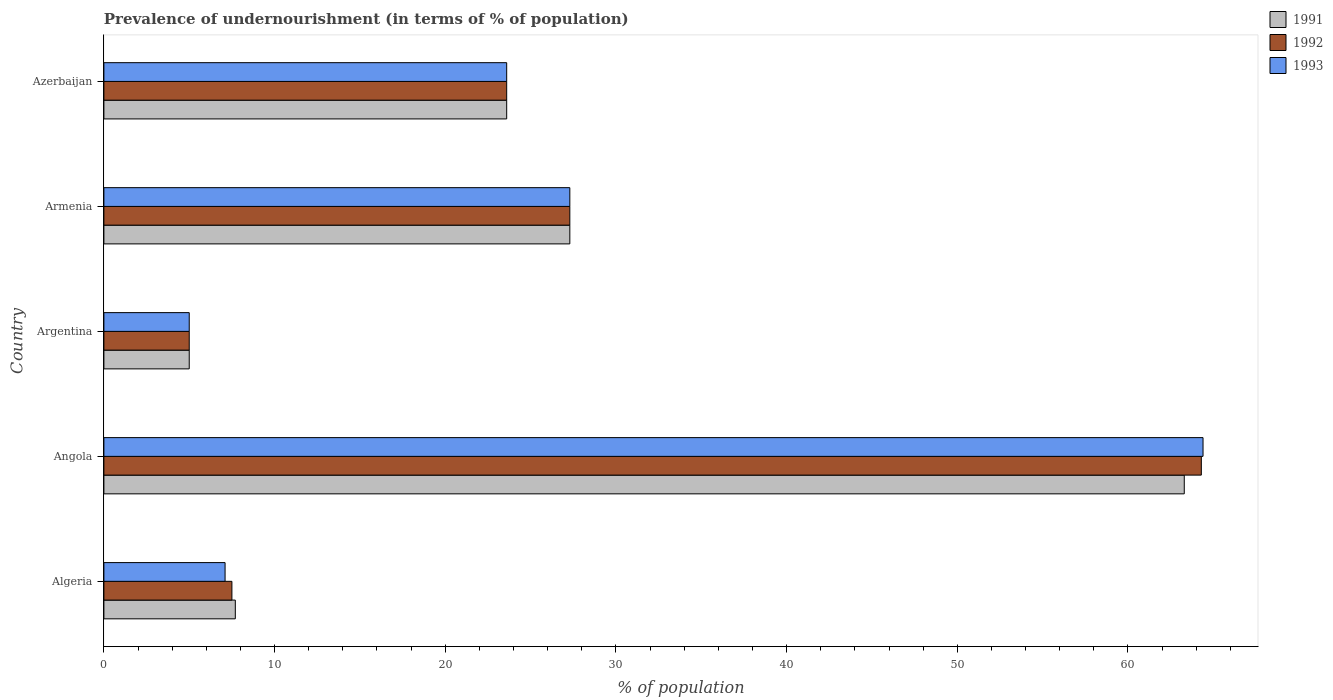What is the label of the 2nd group of bars from the top?
Your answer should be compact. Armenia. What is the percentage of undernourished population in 1991 in Angola?
Make the answer very short. 63.3. Across all countries, what is the maximum percentage of undernourished population in 1992?
Make the answer very short. 64.3. Across all countries, what is the minimum percentage of undernourished population in 1993?
Offer a very short reply. 5. In which country was the percentage of undernourished population in 1991 maximum?
Make the answer very short. Angola. What is the total percentage of undernourished population in 1992 in the graph?
Provide a short and direct response. 127.7. What is the difference between the percentage of undernourished population in 1993 in Algeria and that in Armenia?
Give a very brief answer. -20.2. What is the average percentage of undernourished population in 1992 per country?
Provide a short and direct response. 25.54. What is the difference between the percentage of undernourished population in 1993 and percentage of undernourished population in 1991 in Azerbaijan?
Give a very brief answer. 0. What is the ratio of the percentage of undernourished population in 1991 in Angola to that in Argentina?
Your answer should be very brief. 12.66. Is the percentage of undernourished population in 1993 in Argentina less than that in Azerbaijan?
Keep it short and to the point. Yes. Is the difference between the percentage of undernourished population in 1993 in Armenia and Azerbaijan greater than the difference between the percentage of undernourished population in 1991 in Armenia and Azerbaijan?
Ensure brevity in your answer.  No. What is the difference between the highest and the second highest percentage of undernourished population in 1992?
Make the answer very short. 37. What is the difference between the highest and the lowest percentage of undernourished population in 1991?
Offer a very short reply. 58.3. What does the 3rd bar from the bottom in Angola represents?
Ensure brevity in your answer.  1993. Is it the case that in every country, the sum of the percentage of undernourished population in 1993 and percentage of undernourished population in 1991 is greater than the percentage of undernourished population in 1992?
Provide a short and direct response. Yes. How many bars are there?
Make the answer very short. 15. Are all the bars in the graph horizontal?
Provide a succinct answer. Yes. How many countries are there in the graph?
Your response must be concise. 5. What is the difference between two consecutive major ticks on the X-axis?
Your response must be concise. 10. Where does the legend appear in the graph?
Make the answer very short. Top right. How many legend labels are there?
Make the answer very short. 3. What is the title of the graph?
Provide a succinct answer. Prevalence of undernourishment (in terms of % of population). What is the label or title of the X-axis?
Your response must be concise. % of population. What is the label or title of the Y-axis?
Your response must be concise. Country. What is the % of population of 1992 in Algeria?
Your answer should be very brief. 7.5. What is the % of population of 1991 in Angola?
Offer a very short reply. 63.3. What is the % of population in 1992 in Angola?
Your answer should be compact. 64.3. What is the % of population in 1993 in Angola?
Offer a terse response. 64.4. What is the % of population of 1993 in Argentina?
Your response must be concise. 5. What is the % of population of 1991 in Armenia?
Your answer should be compact. 27.3. What is the % of population of 1992 in Armenia?
Ensure brevity in your answer.  27.3. What is the % of population in 1993 in Armenia?
Provide a succinct answer. 27.3. What is the % of population of 1991 in Azerbaijan?
Provide a succinct answer. 23.6. What is the % of population of 1992 in Azerbaijan?
Keep it short and to the point. 23.6. What is the % of population in 1993 in Azerbaijan?
Provide a succinct answer. 23.6. Across all countries, what is the maximum % of population in 1991?
Give a very brief answer. 63.3. Across all countries, what is the maximum % of population of 1992?
Offer a very short reply. 64.3. Across all countries, what is the maximum % of population of 1993?
Offer a terse response. 64.4. What is the total % of population in 1991 in the graph?
Keep it short and to the point. 126.9. What is the total % of population of 1992 in the graph?
Make the answer very short. 127.7. What is the total % of population of 1993 in the graph?
Keep it short and to the point. 127.4. What is the difference between the % of population of 1991 in Algeria and that in Angola?
Provide a succinct answer. -55.6. What is the difference between the % of population of 1992 in Algeria and that in Angola?
Ensure brevity in your answer.  -56.8. What is the difference between the % of population of 1993 in Algeria and that in Angola?
Offer a terse response. -57.3. What is the difference between the % of population in 1993 in Algeria and that in Argentina?
Ensure brevity in your answer.  2.1. What is the difference between the % of population of 1991 in Algeria and that in Armenia?
Offer a terse response. -19.6. What is the difference between the % of population of 1992 in Algeria and that in Armenia?
Your response must be concise. -19.8. What is the difference between the % of population in 1993 in Algeria and that in Armenia?
Give a very brief answer. -20.2. What is the difference between the % of population of 1991 in Algeria and that in Azerbaijan?
Offer a very short reply. -15.9. What is the difference between the % of population in 1992 in Algeria and that in Azerbaijan?
Provide a short and direct response. -16.1. What is the difference between the % of population in 1993 in Algeria and that in Azerbaijan?
Provide a short and direct response. -16.5. What is the difference between the % of population of 1991 in Angola and that in Argentina?
Make the answer very short. 58.3. What is the difference between the % of population in 1992 in Angola and that in Argentina?
Provide a short and direct response. 59.3. What is the difference between the % of population of 1993 in Angola and that in Argentina?
Your answer should be very brief. 59.4. What is the difference between the % of population in 1991 in Angola and that in Armenia?
Your response must be concise. 36. What is the difference between the % of population of 1993 in Angola and that in Armenia?
Give a very brief answer. 37.1. What is the difference between the % of population in 1991 in Angola and that in Azerbaijan?
Provide a short and direct response. 39.7. What is the difference between the % of population of 1992 in Angola and that in Azerbaijan?
Offer a very short reply. 40.7. What is the difference between the % of population of 1993 in Angola and that in Azerbaijan?
Your response must be concise. 40.8. What is the difference between the % of population in 1991 in Argentina and that in Armenia?
Make the answer very short. -22.3. What is the difference between the % of population in 1992 in Argentina and that in Armenia?
Make the answer very short. -22.3. What is the difference between the % of population in 1993 in Argentina and that in Armenia?
Give a very brief answer. -22.3. What is the difference between the % of population of 1991 in Argentina and that in Azerbaijan?
Your answer should be compact. -18.6. What is the difference between the % of population in 1992 in Argentina and that in Azerbaijan?
Your answer should be compact. -18.6. What is the difference between the % of population in 1993 in Argentina and that in Azerbaijan?
Make the answer very short. -18.6. What is the difference between the % of population of 1991 in Armenia and that in Azerbaijan?
Offer a terse response. 3.7. What is the difference between the % of population in 1992 in Armenia and that in Azerbaijan?
Your response must be concise. 3.7. What is the difference between the % of population of 1993 in Armenia and that in Azerbaijan?
Offer a very short reply. 3.7. What is the difference between the % of population of 1991 in Algeria and the % of population of 1992 in Angola?
Make the answer very short. -56.6. What is the difference between the % of population of 1991 in Algeria and the % of population of 1993 in Angola?
Offer a terse response. -56.7. What is the difference between the % of population of 1992 in Algeria and the % of population of 1993 in Angola?
Make the answer very short. -56.9. What is the difference between the % of population in 1991 in Algeria and the % of population in 1992 in Armenia?
Provide a short and direct response. -19.6. What is the difference between the % of population in 1991 in Algeria and the % of population in 1993 in Armenia?
Make the answer very short. -19.6. What is the difference between the % of population of 1992 in Algeria and the % of population of 1993 in Armenia?
Provide a succinct answer. -19.8. What is the difference between the % of population in 1991 in Algeria and the % of population in 1992 in Azerbaijan?
Give a very brief answer. -15.9. What is the difference between the % of population of 1991 in Algeria and the % of population of 1993 in Azerbaijan?
Your answer should be compact. -15.9. What is the difference between the % of population of 1992 in Algeria and the % of population of 1993 in Azerbaijan?
Give a very brief answer. -16.1. What is the difference between the % of population in 1991 in Angola and the % of population in 1992 in Argentina?
Ensure brevity in your answer.  58.3. What is the difference between the % of population of 1991 in Angola and the % of population of 1993 in Argentina?
Ensure brevity in your answer.  58.3. What is the difference between the % of population of 1992 in Angola and the % of population of 1993 in Argentina?
Your answer should be compact. 59.3. What is the difference between the % of population of 1991 in Angola and the % of population of 1992 in Armenia?
Keep it short and to the point. 36. What is the difference between the % of population in 1991 in Angola and the % of population in 1992 in Azerbaijan?
Ensure brevity in your answer.  39.7. What is the difference between the % of population in 1991 in Angola and the % of population in 1993 in Azerbaijan?
Provide a short and direct response. 39.7. What is the difference between the % of population in 1992 in Angola and the % of population in 1993 in Azerbaijan?
Provide a succinct answer. 40.7. What is the difference between the % of population in 1991 in Argentina and the % of population in 1992 in Armenia?
Provide a short and direct response. -22.3. What is the difference between the % of population in 1991 in Argentina and the % of population in 1993 in Armenia?
Your response must be concise. -22.3. What is the difference between the % of population in 1992 in Argentina and the % of population in 1993 in Armenia?
Provide a short and direct response. -22.3. What is the difference between the % of population of 1991 in Argentina and the % of population of 1992 in Azerbaijan?
Keep it short and to the point. -18.6. What is the difference between the % of population of 1991 in Argentina and the % of population of 1993 in Azerbaijan?
Your answer should be compact. -18.6. What is the difference between the % of population of 1992 in Argentina and the % of population of 1993 in Azerbaijan?
Offer a terse response. -18.6. What is the difference between the % of population in 1991 in Armenia and the % of population in 1993 in Azerbaijan?
Your answer should be compact. 3.7. What is the difference between the % of population of 1992 in Armenia and the % of population of 1993 in Azerbaijan?
Keep it short and to the point. 3.7. What is the average % of population in 1991 per country?
Keep it short and to the point. 25.38. What is the average % of population in 1992 per country?
Give a very brief answer. 25.54. What is the average % of population in 1993 per country?
Keep it short and to the point. 25.48. What is the difference between the % of population of 1991 and % of population of 1993 in Angola?
Your response must be concise. -1.1. What is the difference between the % of population of 1992 and % of population of 1993 in Angola?
Provide a succinct answer. -0.1. What is the difference between the % of population in 1992 and % of population in 1993 in Argentina?
Give a very brief answer. 0. What is the difference between the % of population in 1991 and % of population in 1992 in Armenia?
Make the answer very short. 0. What is the difference between the % of population of 1992 and % of population of 1993 in Armenia?
Your response must be concise. 0. What is the difference between the % of population in 1991 and % of population in 1992 in Azerbaijan?
Your answer should be very brief. 0. What is the difference between the % of population of 1991 and % of population of 1993 in Azerbaijan?
Keep it short and to the point. 0. What is the difference between the % of population in 1992 and % of population in 1993 in Azerbaijan?
Provide a short and direct response. 0. What is the ratio of the % of population of 1991 in Algeria to that in Angola?
Your answer should be compact. 0.12. What is the ratio of the % of population in 1992 in Algeria to that in Angola?
Keep it short and to the point. 0.12. What is the ratio of the % of population of 1993 in Algeria to that in Angola?
Your answer should be compact. 0.11. What is the ratio of the % of population in 1991 in Algeria to that in Argentina?
Make the answer very short. 1.54. What is the ratio of the % of population of 1993 in Algeria to that in Argentina?
Give a very brief answer. 1.42. What is the ratio of the % of population of 1991 in Algeria to that in Armenia?
Your answer should be very brief. 0.28. What is the ratio of the % of population of 1992 in Algeria to that in Armenia?
Provide a short and direct response. 0.27. What is the ratio of the % of population of 1993 in Algeria to that in Armenia?
Make the answer very short. 0.26. What is the ratio of the % of population of 1991 in Algeria to that in Azerbaijan?
Give a very brief answer. 0.33. What is the ratio of the % of population of 1992 in Algeria to that in Azerbaijan?
Provide a short and direct response. 0.32. What is the ratio of the % of population of 1993 in Algeria to that in Azerbaijan?
Provide a short and direct response. 0.3. What is the ratio of the % of population of 1991 in Angola to that in Argentina?
Keep it short and to the point. 12.66. What is the ratio of the % of population of 1992 in Angola to that in Argentina?
Your answer should be very brief. 12.86. What is the ratio of the % of population of 1993 in Angola to that in Argentina?
Your answer should be very brief. 12.88. What is the ratio of the % of population of 1991 in Angola to that in Armenia?
Offer a terse response. 2.32. What is the ratio of the % of population of 1992 in Angola to that in Armenia?
Offer a very short reply. 2.36. What is the ratio of the % of population in 1993 in Angola to that in Armenia?
Provide a succinct answer. 2.36. What is the ratio of the % of population of 1991 in Angola to that in Azerbaijan?
Provide a succinct answer. 2.68. What is the ratio of the % of population in 1992 in Angola to that in Azerbaijan?
Provide a succinct answer. 2.72. What is the ratio of the % of population of 1993 in Angola to that in Azerbaijan?
Make the answer very short. 2.73. What is the ratio of the % of population of 1991 in Argentina to that in Armenia?
Ensure brevity in your answer.  0.18. What is the ratio of the % of population in 1992 in Argentina to that in Armenia?
Your response must be concise. 0.18. What is the ratio of the % of population in 1993 in Argentina to that in Armenia?
Offer a very short reply. 0.18. What is the ratio of the % of population of 1991 in Argentina to that in Azerbaijan?
Give a very brief answer. 0.21. What is the ratio of the % of population of 1992 in Argentina to that in Azerbaijan?
Your answer should be compact. 0.21. What is the ratio of the % of population in 1993 in Argentina to that in Azerbaijan?
Your answer should be compact. 0.21. What is the ratio of the % of population in 1991 in Armenia to that in Azerbaijan?
Keep it short and to the point. 1.16. What is the ratio of the % of population of 1992 in Armenia to that in Azerbaijan?
Provide a short and direct response. 1.16. What is the ratio of the % of population in 1993 in Armenia to that in Azerbaijan?
Your response must be concise. 1.16. What is the difference between the highest and the second highest % of population in 1991?
Ensure brevity in your answer.  36. What is the difference between the highest and the second highest % of population in 1993?
Your answer should be very brief. 37.1. What is the difference between the highest and the lowest % of population in 1991?
Keep it short and to the point. 58.3. What is the difference between the highest and the lowest % of population in 1992?
Ensure brevity in your answer.  59.3. What is the difference between the highest and the lowest % of population in 1993?
Your answer should be very brief. 59.4. 